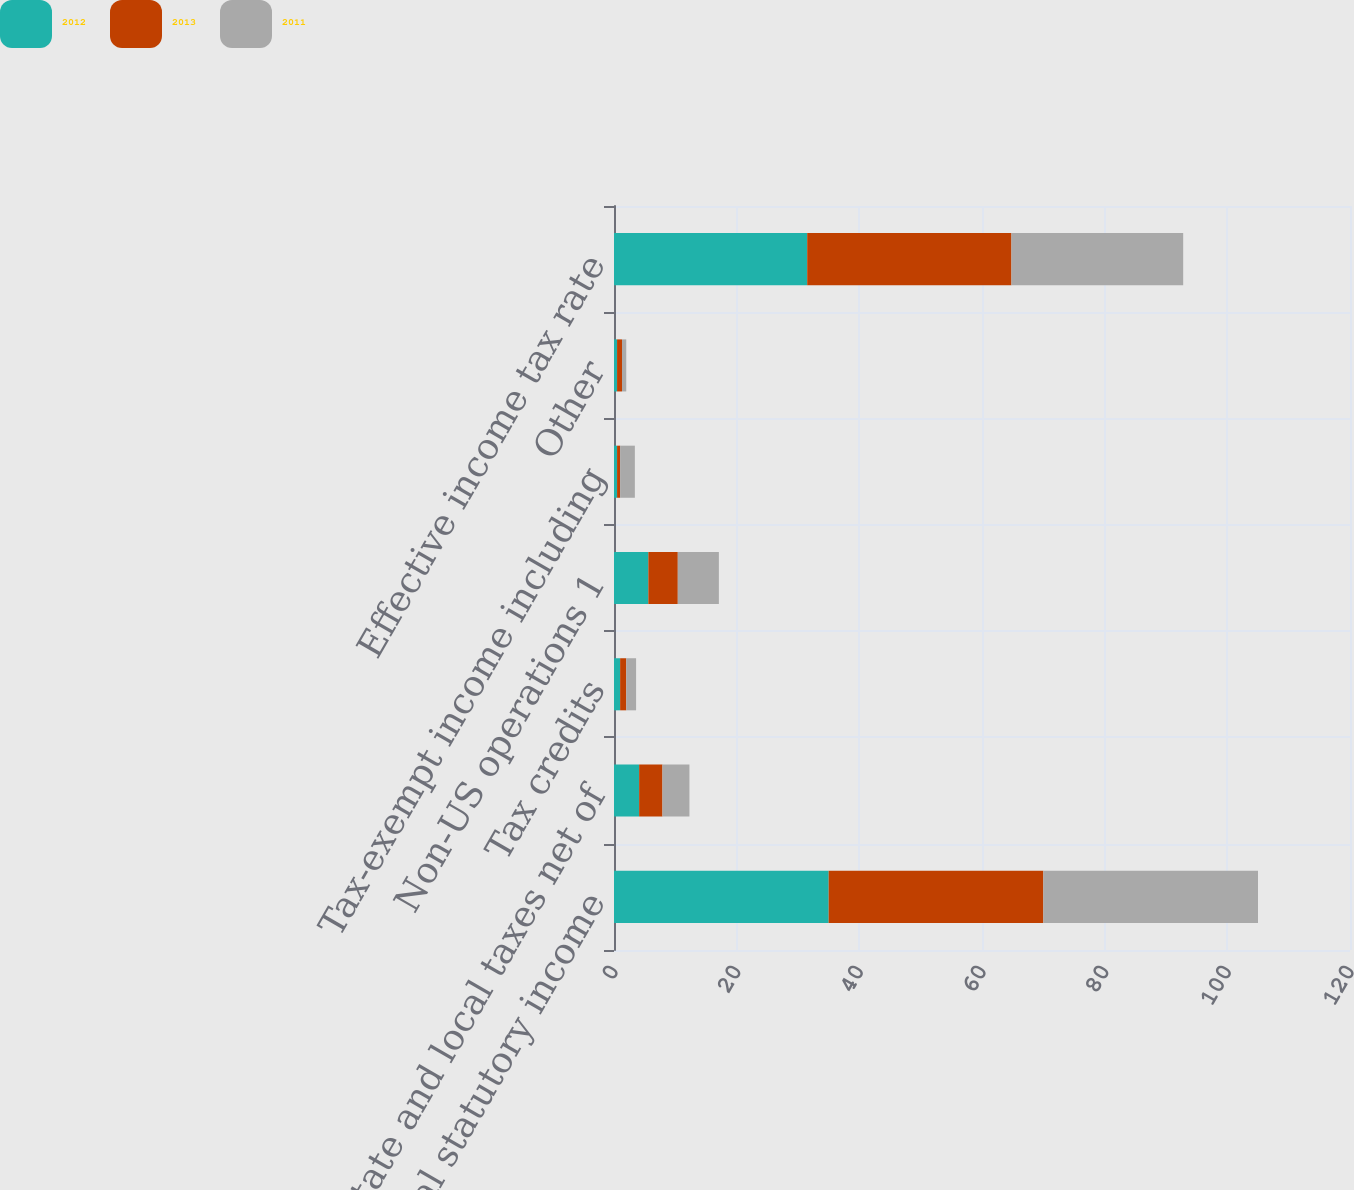<chart> <loc_0><loc_0><loc_500><loc_500><stacked_bar_chart><ecel><fcel>US federal statutory income<fcel>State and local taxes net of<fcel>Tax credits<fcel>Non-US operations 1<fcel>Tax-exempt income including<fcel>Other<fcel>Effective income tax rate<nl><fcel>2012<fcel>35<fcel>4.1<fcel>1<fcel>5.6<fcel>0.5<fcel>0.5<fcel>31.5<nl><fcel>2013<fcel>35<fcel>3.8<fcel>1<fcel>4.8<fcel>0.5<fcel>0.8<fcel>33.3<nl><fcel>2011<fcel>35<fcel>4.4<fcel>1.6<fcel>6.7<fcel>2.4<fcel>0.7<fcel>28<nl></chart> 